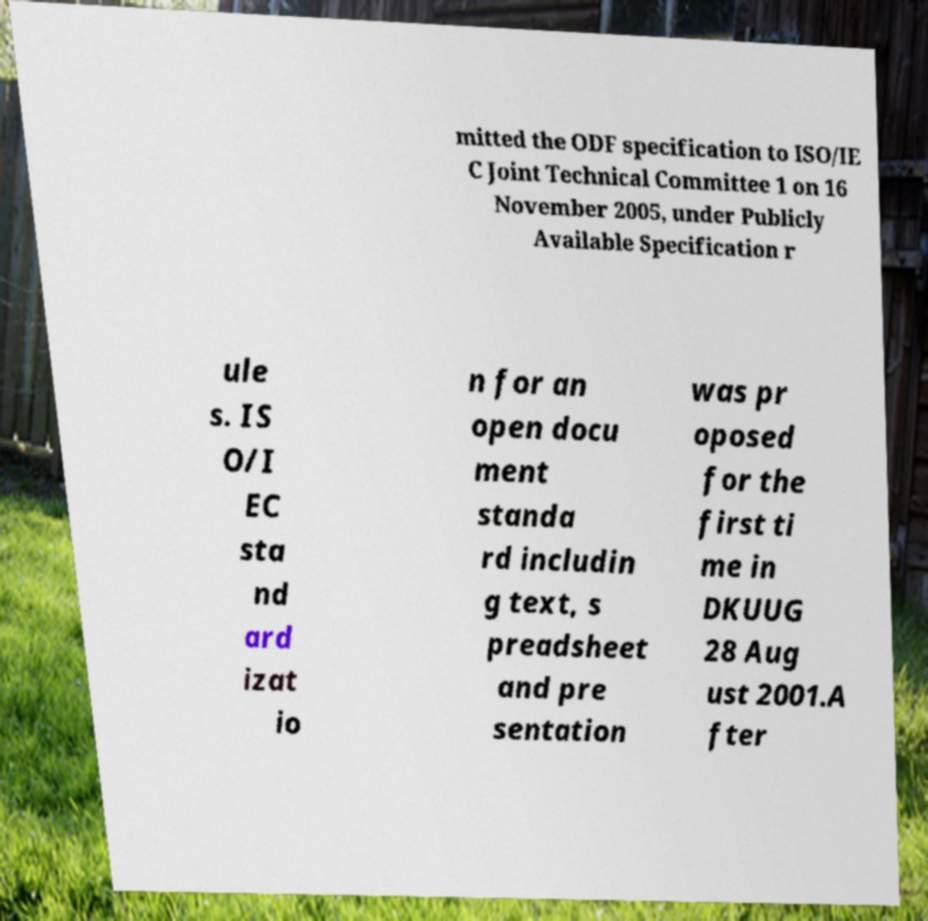Could you assist in decoding the text presented in this image and type it out clearly? mitted the ODF specification to ISO/IE C Joint Technical Committee 1 on 16 November 2005, under Publicly Available Specification r ule s. IS O/I EC sta nd ard izat io n for an open docu ment standa rd includin g text, s preadsheet and pre sentation was pr oposed for the first ti me in DKUUG 28 Aug ust 2001.A fter 